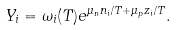Convert formula to latex. <formula><loc_0><loc_0><loc_500><loc_500>Y _ { i } = \omega _ { i } ( T ) e ^ { \mu _ { n } n _ { i } / T + \mu _ { p } z _ { i } / T } .</formula> 